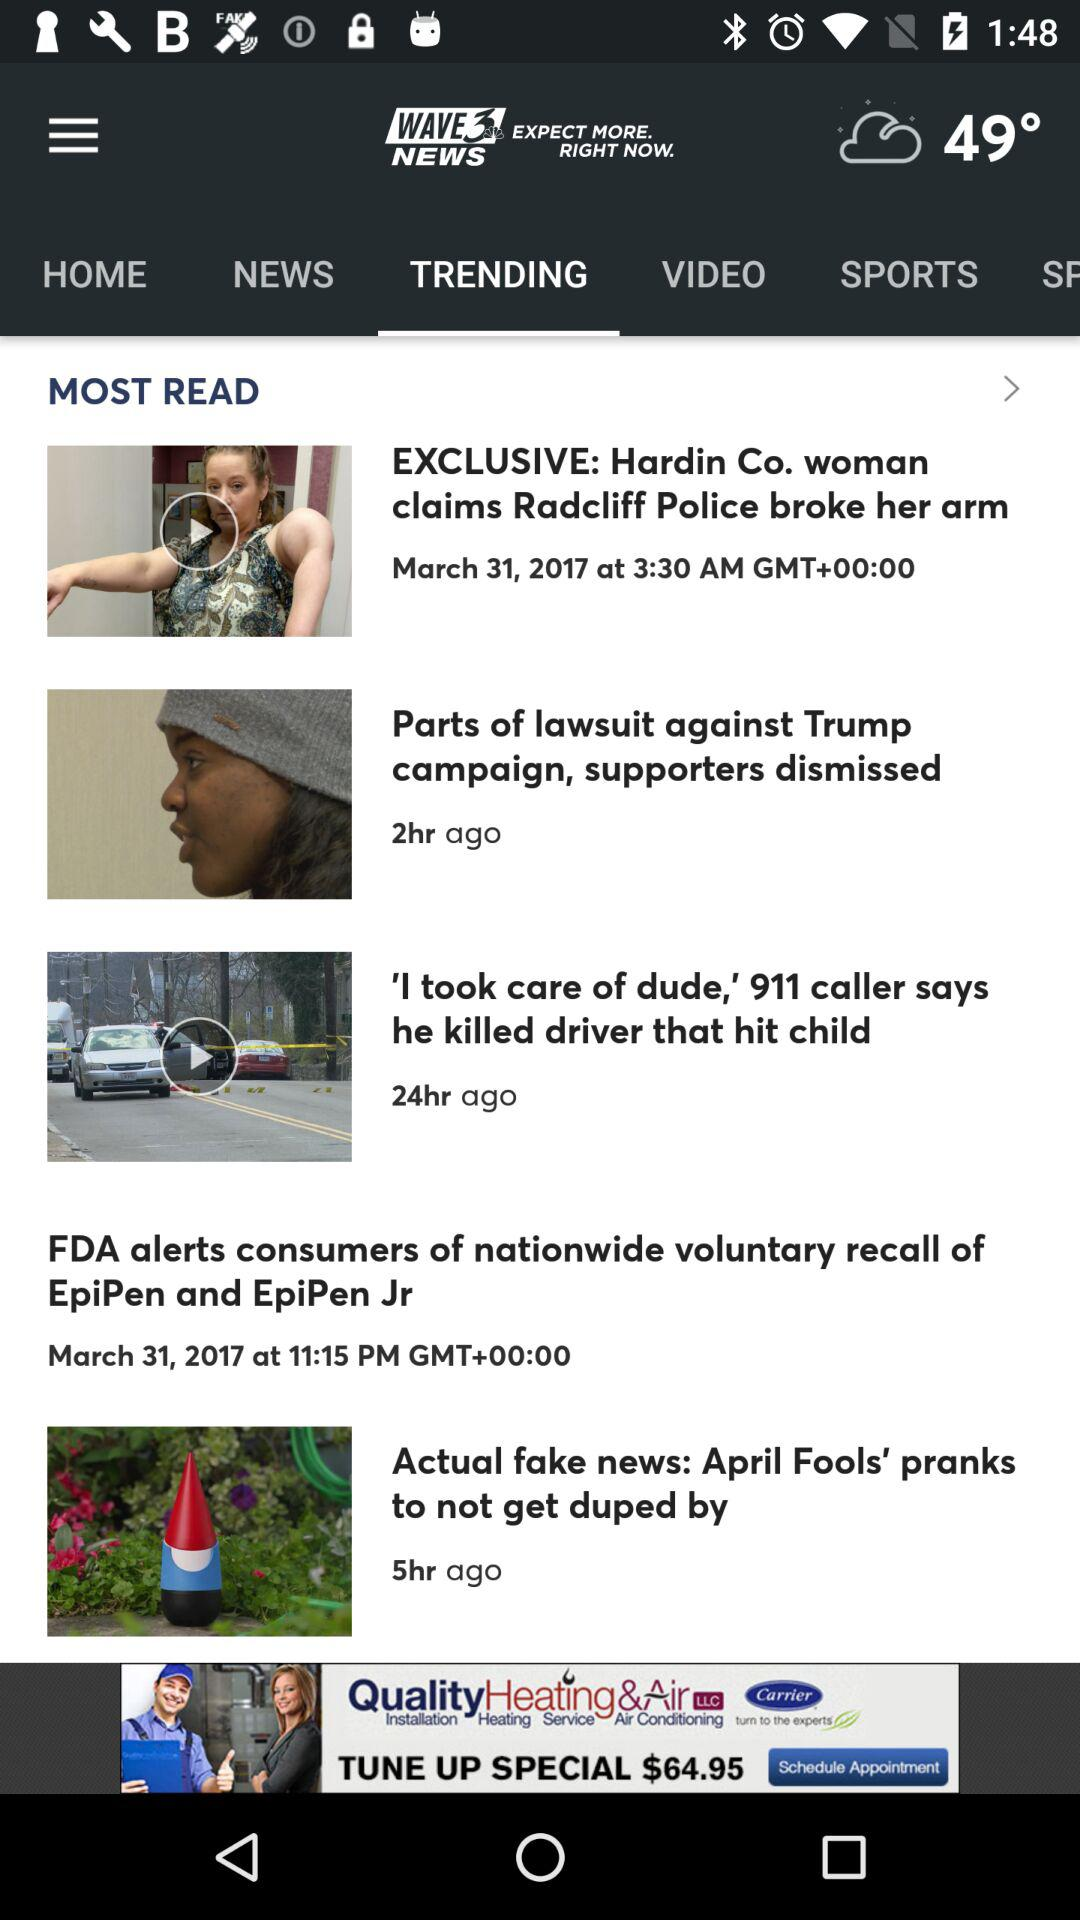What is the news channel name? The channel name is "WAVE 3 NEWS". 